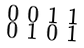Convert formula to latex. <formula><loc_0><loc_0><loc_500><loc_500>\begin{smallmatrix} 0 & 0 & 1 & 1 \\ 0 & 1 & 0 & 1 \end{smallmatrix}</formula> 